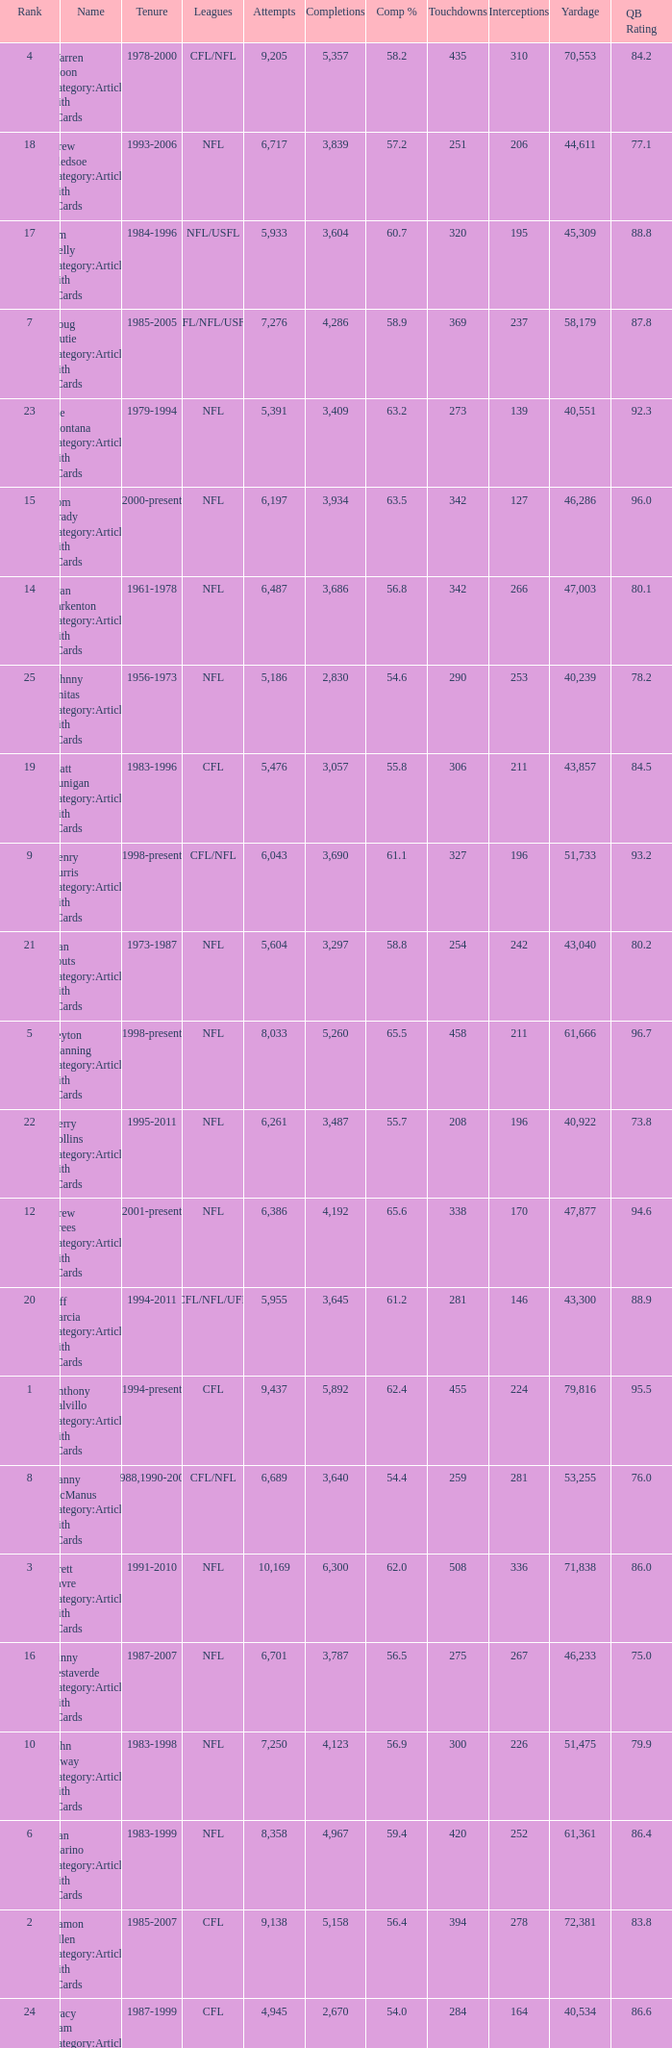What is the rank when there are more than 4,123 completion and the comp percentage is more than 65.6? None. 